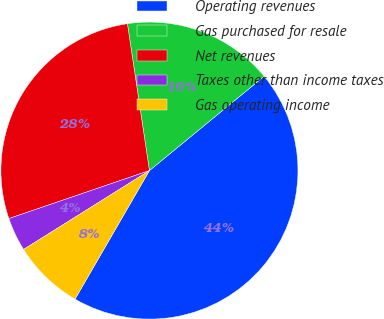<chart> <loc_0><loc_0><loc_500><loc_500><pie_chart><fcel>Operating revenues<fcel>Gas purchased for resale<fcel>Net revenues<fcel>Taxes other than income taxes<fcel>Gas operating income<nl><fcel>44.3%<fcel>16.42%<fcel>27.87%<fcel>3.67%<fcel>7.74%<nl></chart> 